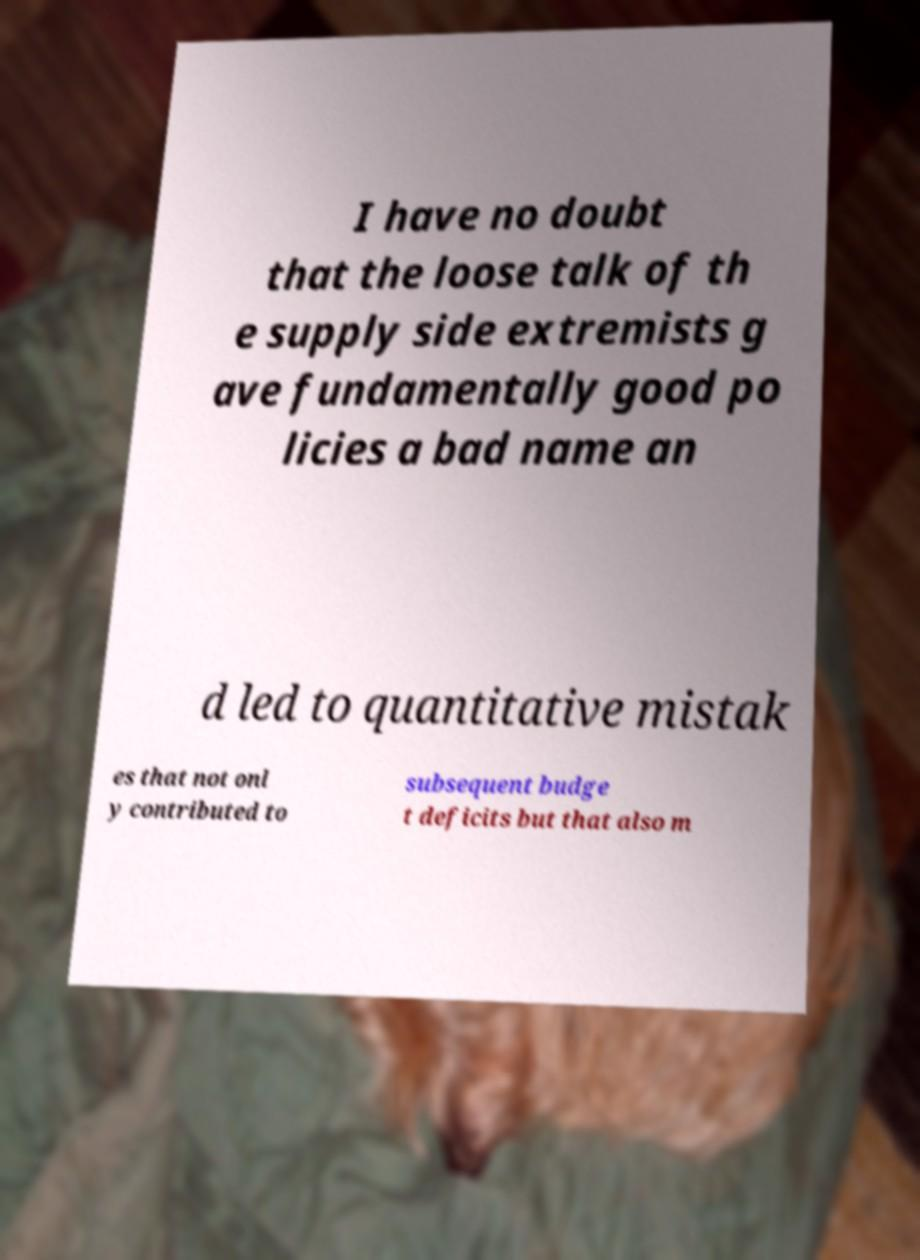Please identify and transcribe the text found in this image. I have no doubt that the loose talk of th e supply side extremists g ave fundamentally good po licies a bad name an d led to quantitative mistak es that not onl y contributed to subsequent budge t deficits but that also m 